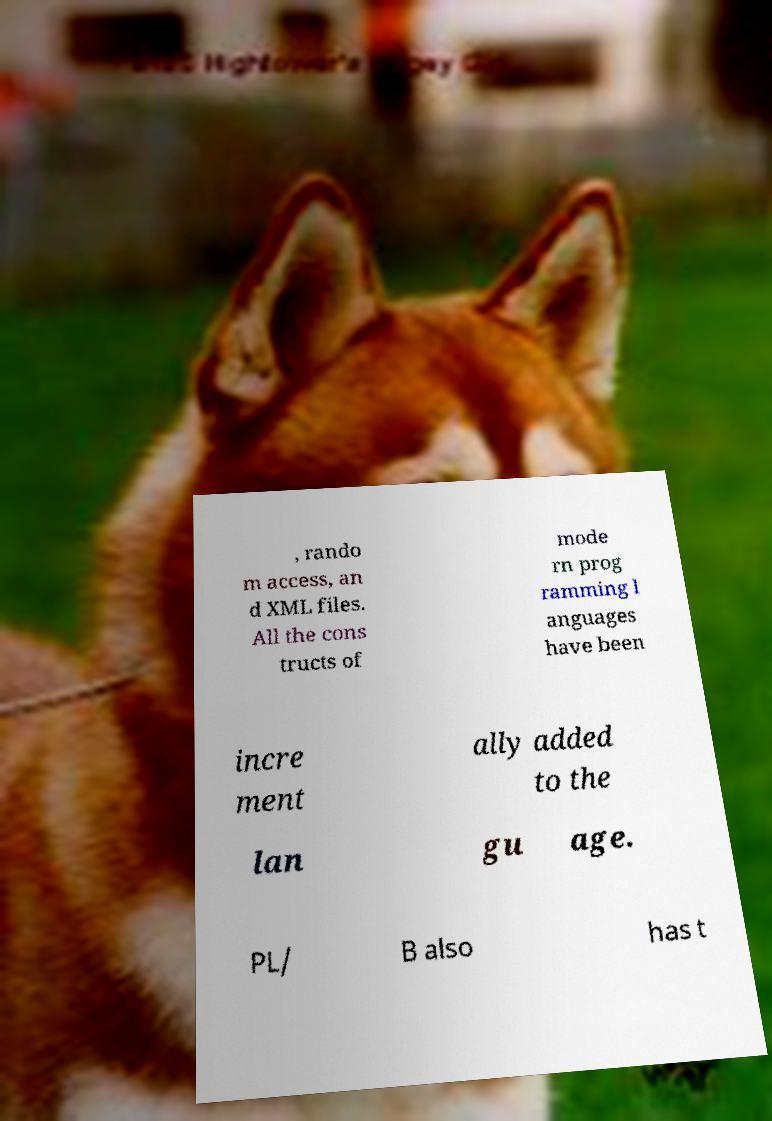Can you accurately transcribe the text from the provided image for me? , rando m access, an d XML files. All the cons tructs of mode rn prog ramming l anguages have been incre ment ally added to the lan gu age. PL/ B also has t 